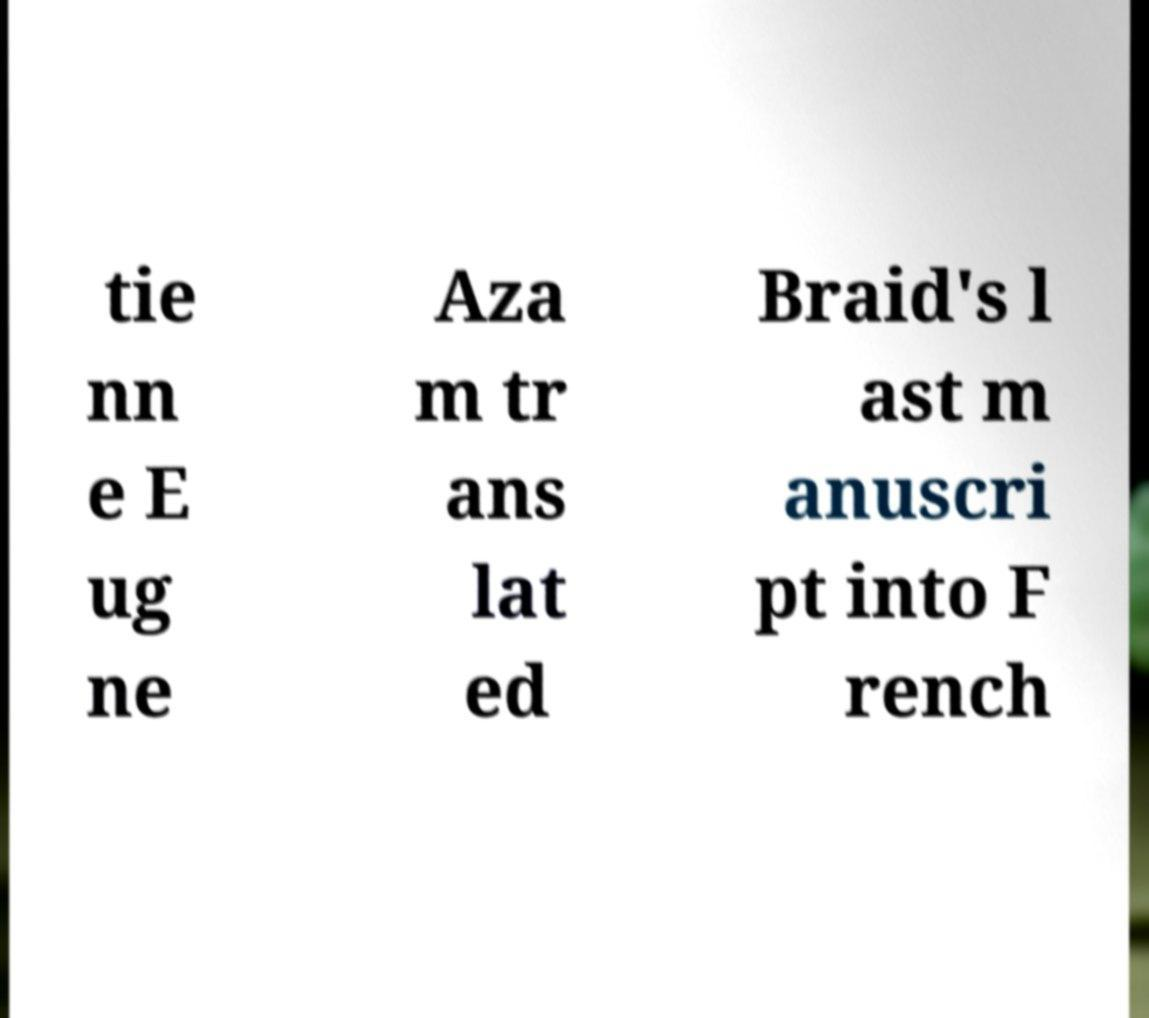For documentation purposes, I need the text within this image transcribed. Could you provide that? tie nn e E ug ne Aza m tr ans lat ed Braid's l ast m anuscri pt into F rench 